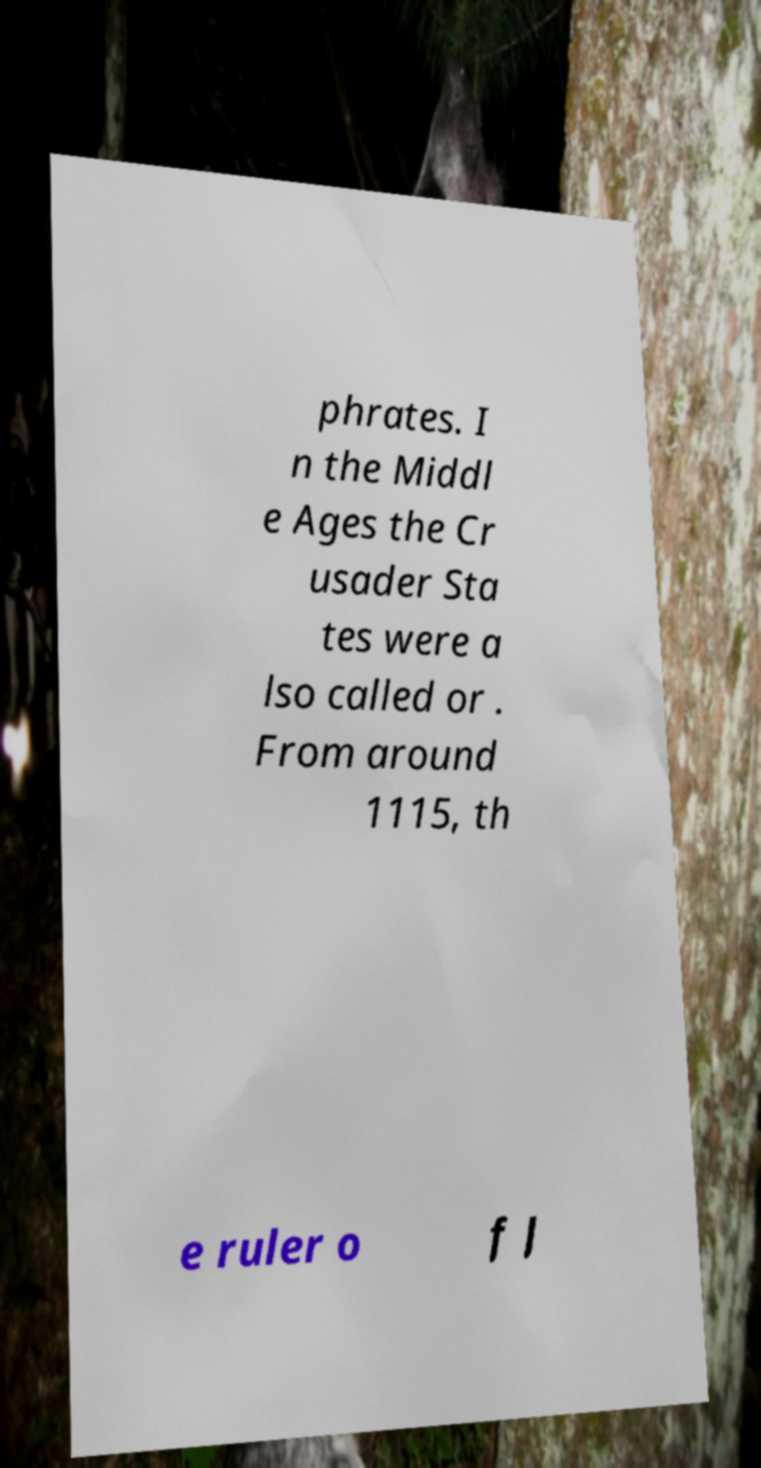Can you read and provide the text displayed in the image?This photo seems to have some interesting text. Can you extract and type it out for me? phrates. I n the Middl e Ages the Cr usader Sta tes were a lso called or . From around 1115, th e ruler o f J 